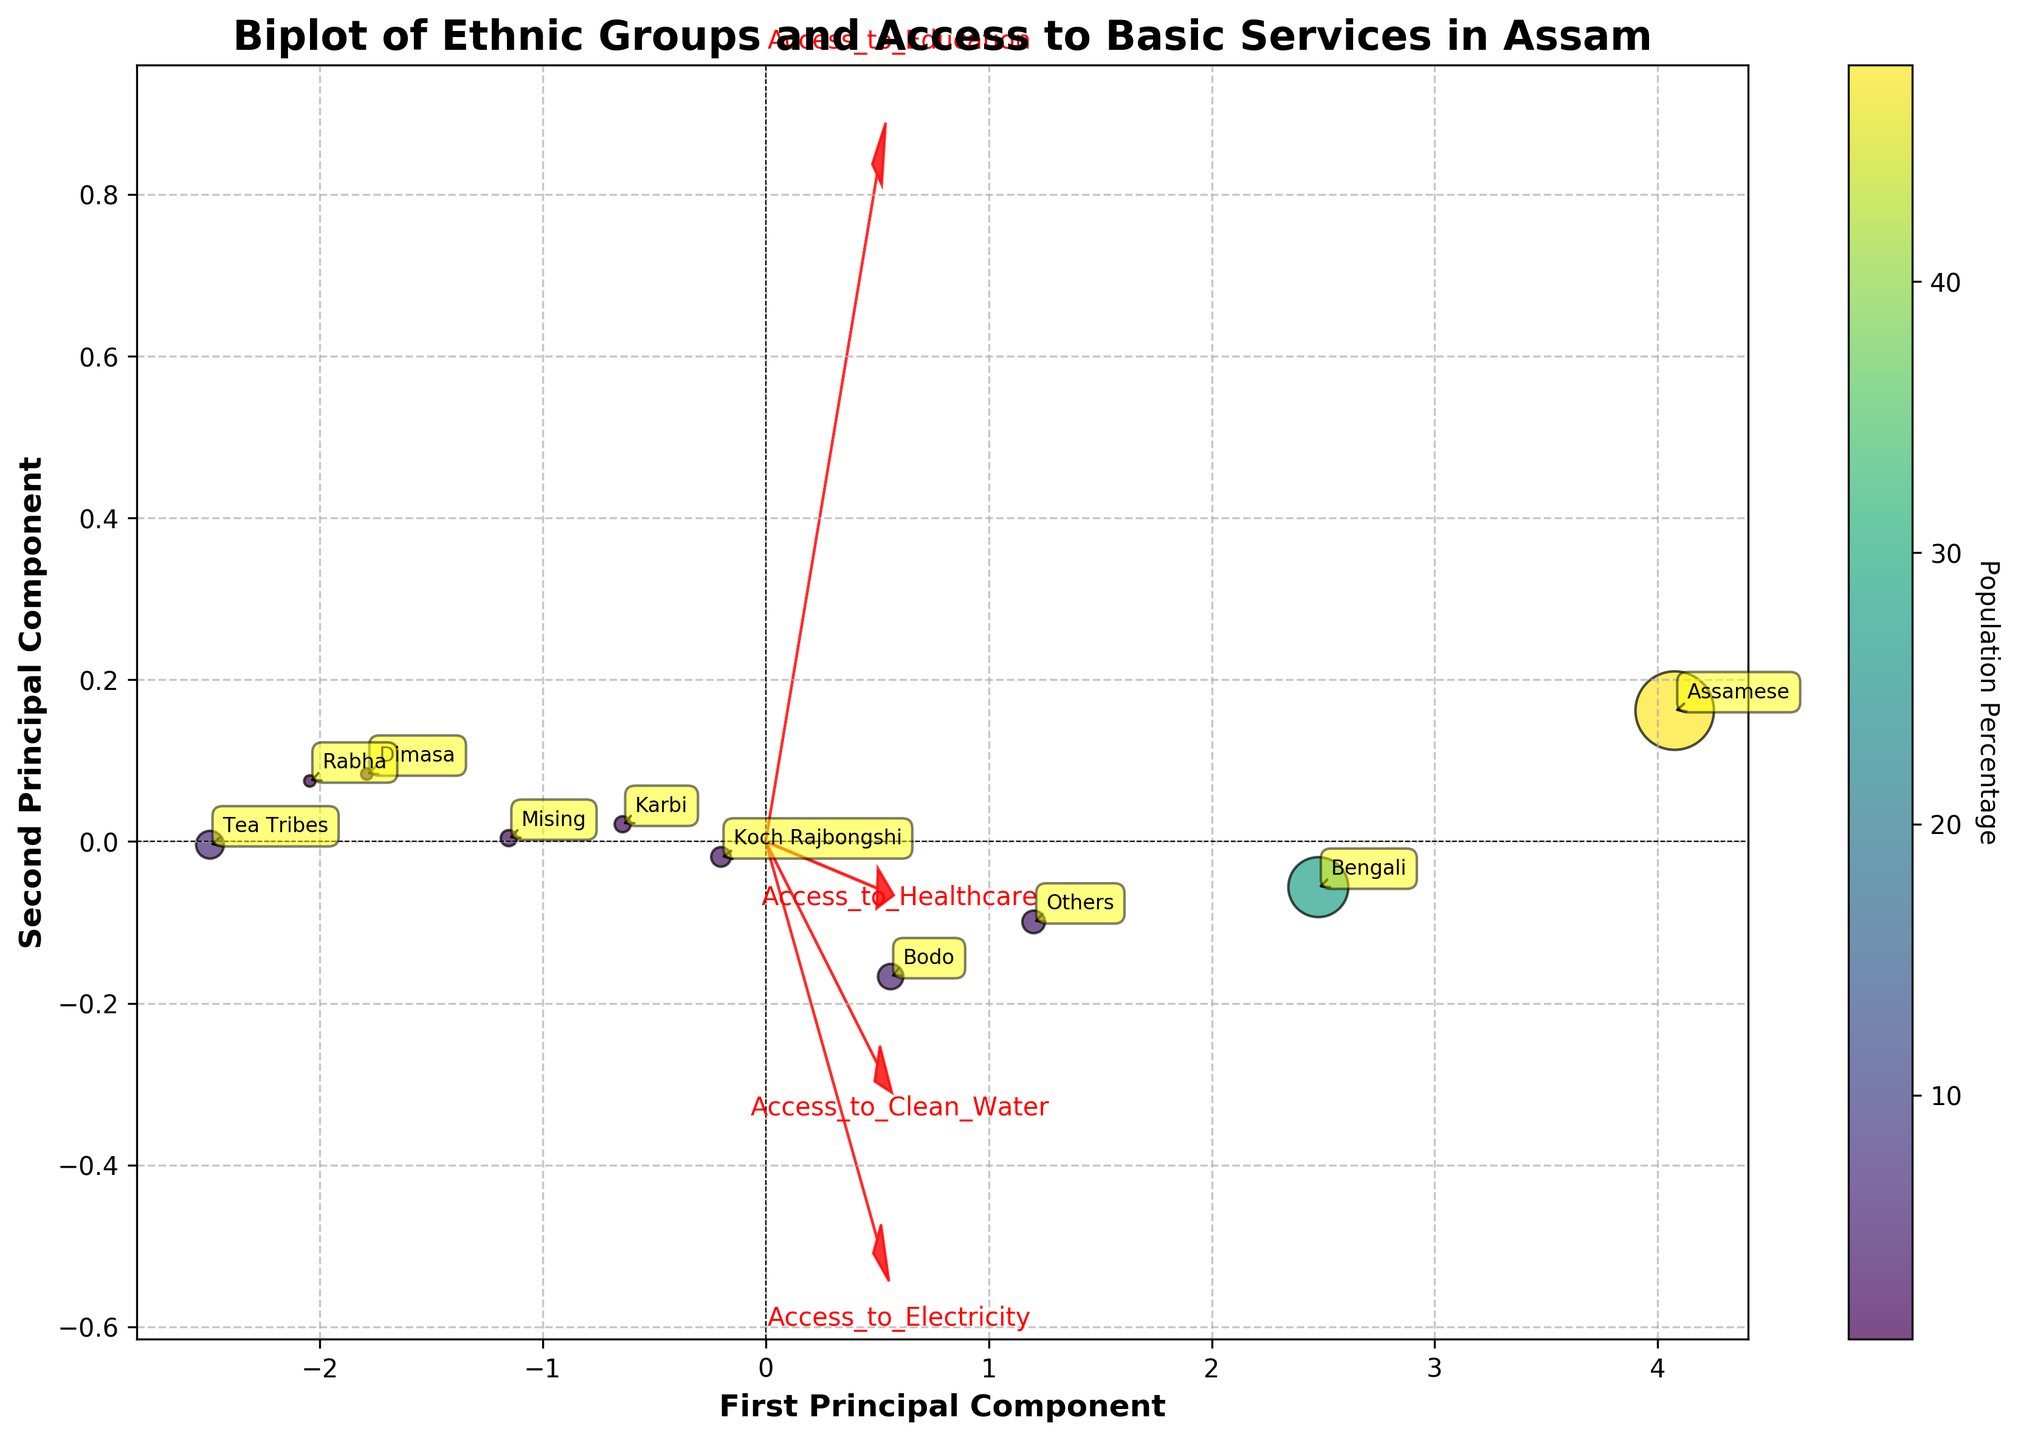what does the title of the figure indicate? The title "Biplot of Ethnic Groups and Access to Basic Services in Assam" indicates that the figure shows a biplot which visualizes the distribution of various ethnic groups in Assam and their correlation with access to basic services
Answer: Distribution of ethnic groups and access to services How many ethnic groups are represented in the figure? By counting the annotating labels on the scatter points, one can determine the total number of ethnic groups presented in the figure.
Answer: 10 Which ethnic group has the highest population percentage? The colorbar and the size of the points can be referred to determine this. The largest points usually indicate the highest population percentage, and by looking at the labels, we identify the group.
Answer: Assamese What does the direction of the arrow representing "Access to Healthcare" imply? In a biplot, the direction of the arrows represents the direction of maximum variance for each feature. The length and direction of the "Access to Healthcare" arrow indicate its correlation with the principal components.
Answer: It's positively correlated with the first principal component Which ethnic group is closest to the "Access_to_Clean_Water" vector? By examining the biplot, identify the point that lies closest to the vector representing "Access_to_Clean_Water". This will be the ethnic group nearest to the arrow.
Answer: Assamese Compare the access to electricity between the Tea Tribes and Koch Rajbongshi. By finding the positions of the Tea Tribes and Koch Rajbongshi on the biplot, we can see which point is closer to the "Access to Electricity" vector and thereby infer who has better access.
Answer: Koch Rajbongshi has better access Based on the figure, which principal component explains more variance in access to education? By observing the loadings of the "Access_to_Education" vector in the biplot on the principal components, determine which component has a higher value towards this feature.
Answer: First principal component What can you infer about the Dimasa group regarding access to the basic services? By locating the Dimasa group on the biplot and observing its position relative to the vectors representing basic services, one can make inferences about their access levels.
Answer: All services are relatively low Identify any two ethnic groups with similar access to basic services. By examining groups that lie close to each other on the biplot and visually inspecting their positions relative to feature vectors, determine which groups have similar access patterns.
Answer: Koch Rajbongshi and Karbi 